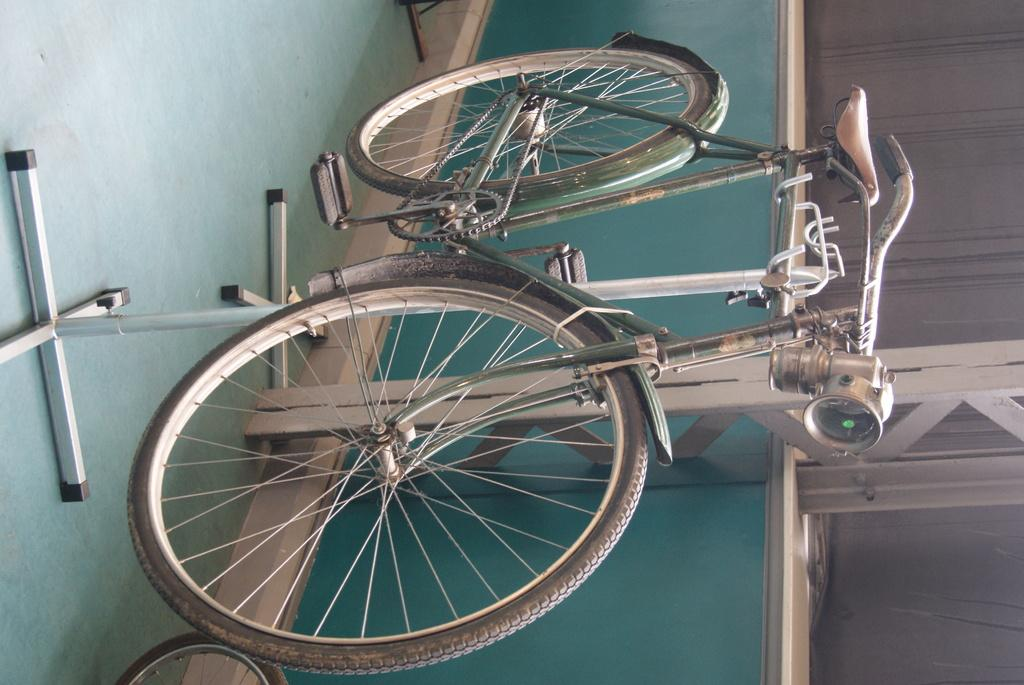What is the main object in the image? There is a bicycle in the image. How is the bicycle positioned in the image? The bicycle is on a stand. What can be seen behind the bicycle? There is a wall behind the bicycle. What part of the bicycle is visible at the bottom of the image? There is a wheel visible at the bottom of the image. What type of disease is being treated by the faucet in the image? There is no faucet present in the image, and therefore no disease treatment can be observed. 